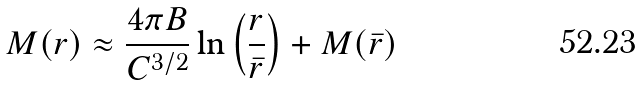Convert formula to latex. <formula><loc_0><loc_0><loc_500><loc_500>M ( r ) \approx \frac { 4 \pi B } { C ^ { 3 / 2 } } \ln \left ( \frac { r } { \bar { r } } \right ) + M ( \bar { r } )</formula> 